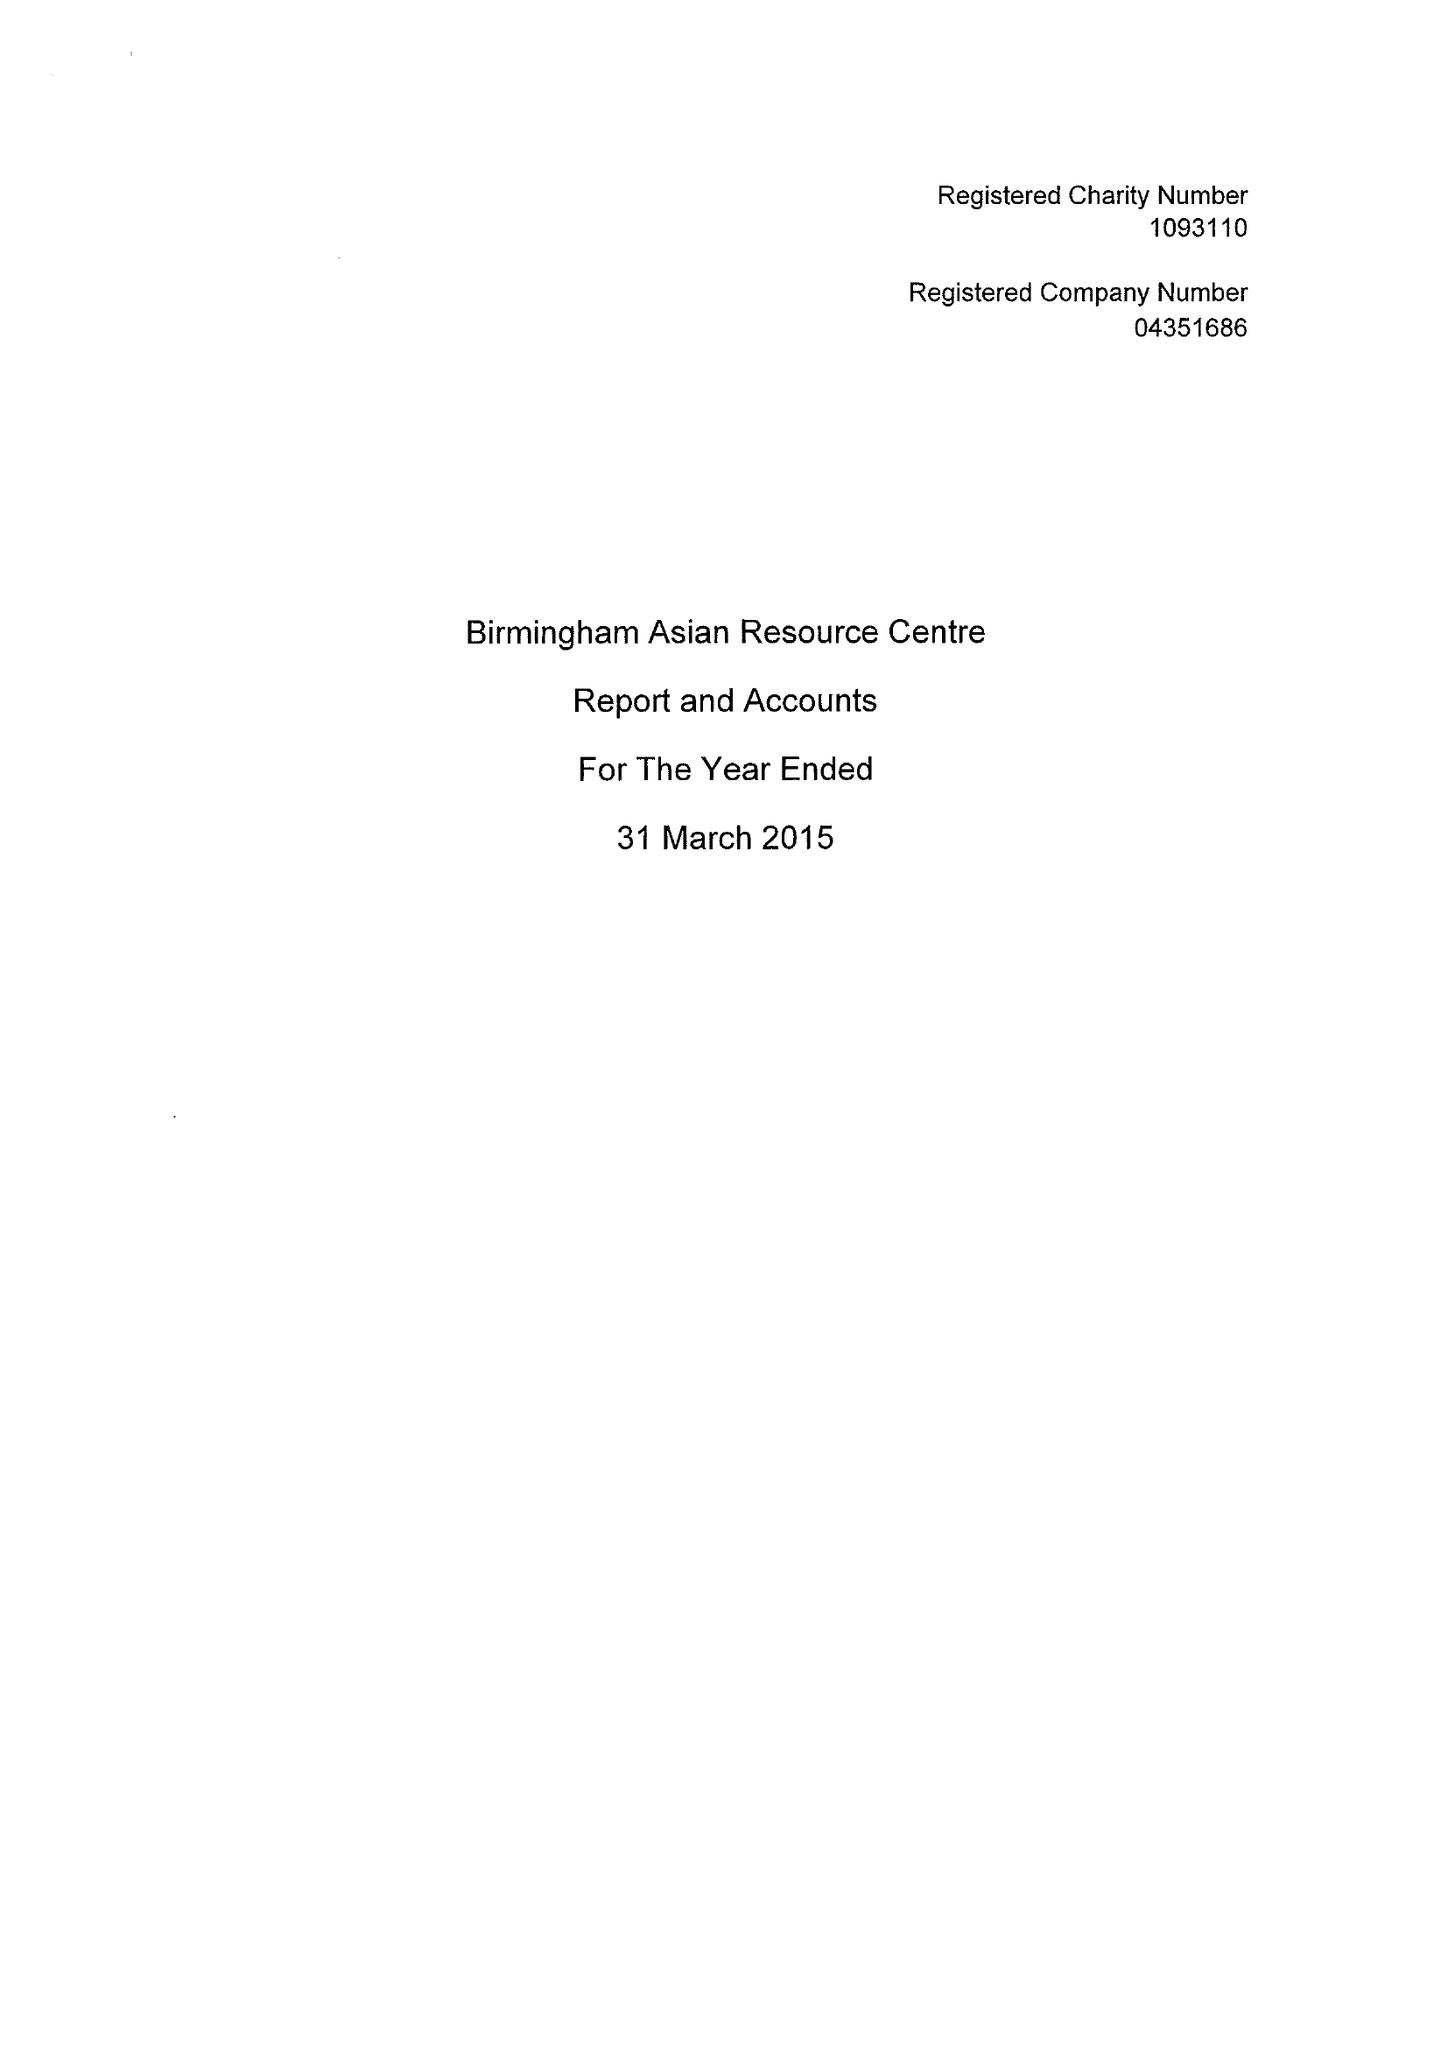What is the value for the report_date?
Answer the question using a single word or phrase. 2015-03-31 